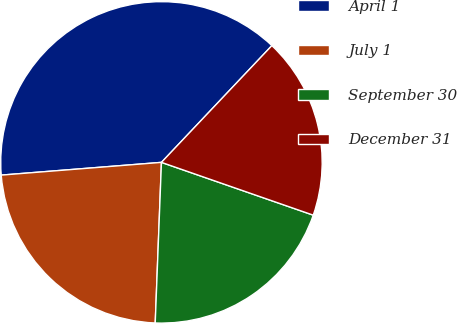<chart> <loc_0><loc_0><loc_500><loc_500><pie_chart><fcel>April 1<fcel>July 1<fcel>September 30<fcel>December 31<nl><fcel>38.32%<fcel>23.12%<fcel>20.29%<fcel>18.27%<nl></chart> 